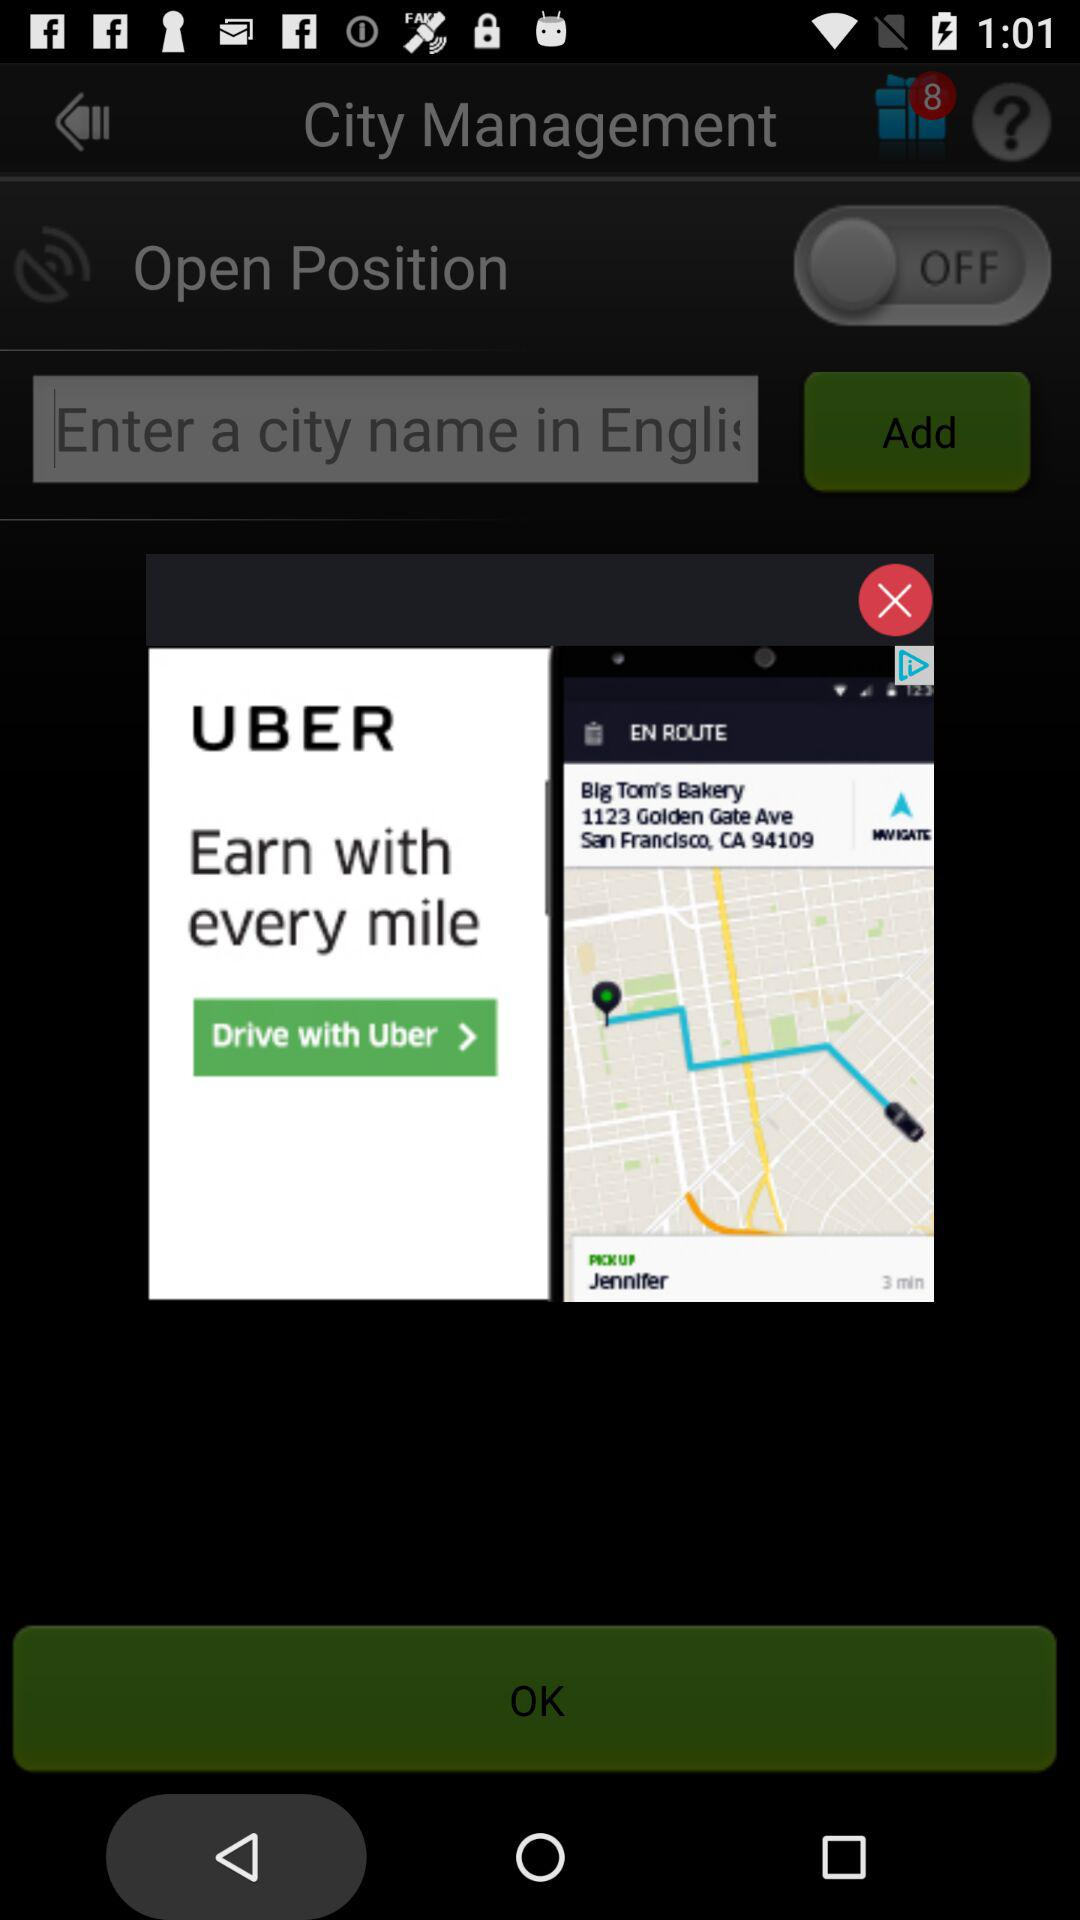How many notifications are pending? There are 8 pending notifications. 